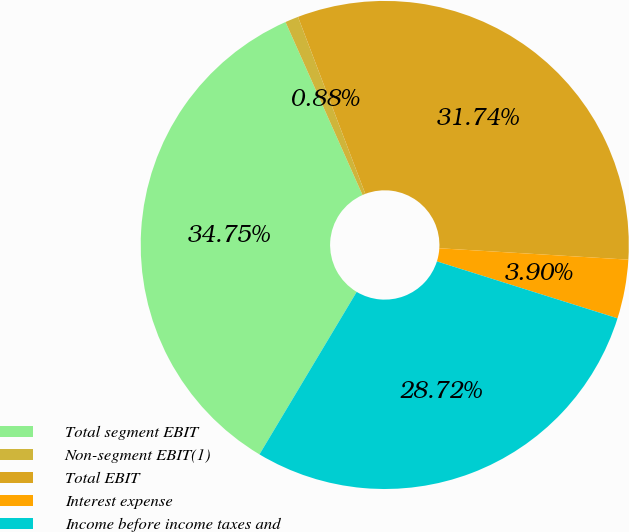<chart> <loc_0><loc_0><loc_500><loc_500><pie_chart><fcel>Total segment EBIT<fcel>Non-segment EBIT(1)<fcel>Total EBIT<fcel>Interest expense<fcel>Income before income taxes and<nl><fcel>34.75%<fcel>0.88%<fcel>31.74%<fcel>3.9%<fcel>28.72%<nl></chart> 